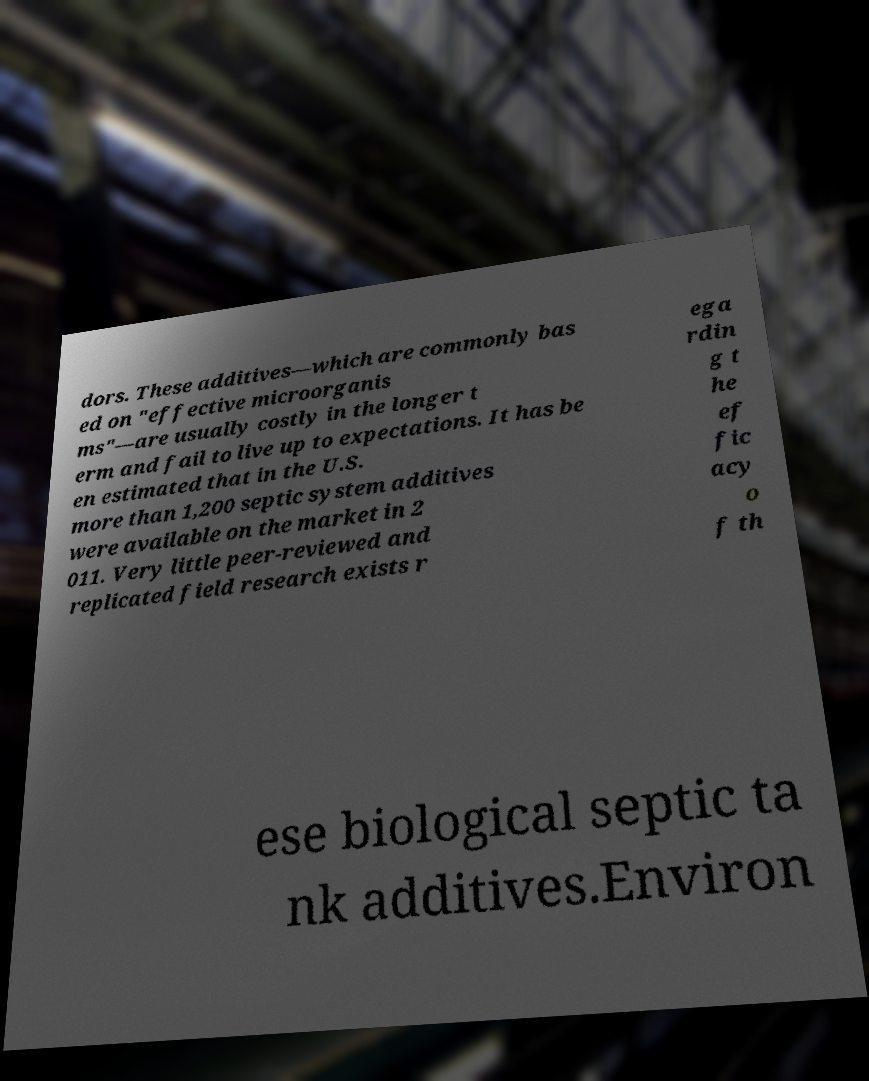For documentation purposes, I need the text within this image transcribed. Could you provide that? dors. These additives—which are commonly bas ed on "effective microorganis ms"—are usually costly in the longer t erm and fail to live up to expectations. It has be en estimated that in the U.S. more than 1,200 septic system additives were available on the market in 2 011. Very little peer-reviewed and replicated field research exists r ega rdin g t he ef fic acy o f th ese biological septic ta nk additives.Environ 